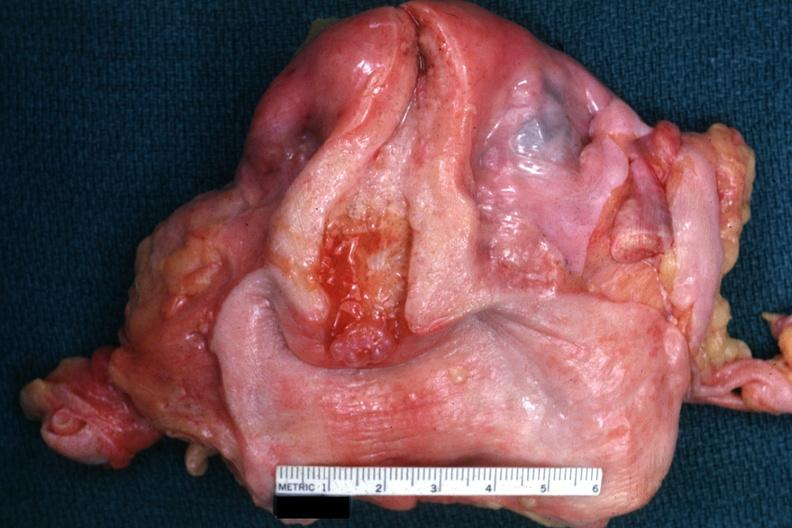where does this belong to?
Answer the question using a single word or phrase. Female reproductive system 